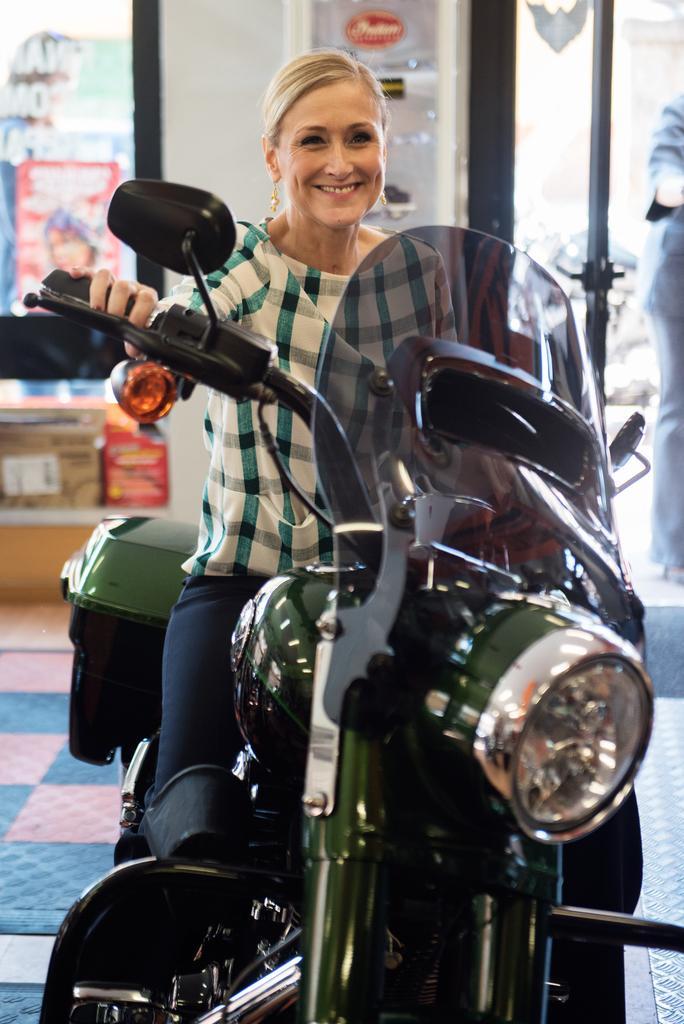Can you describe this image briefly? In the picture there is a woman sitting on a new bike and she is smiling. She is wearing a white shirt, blue jeans and earrings. To the right corner of the image there is another person standing. In the background there is wall, glass and box. 